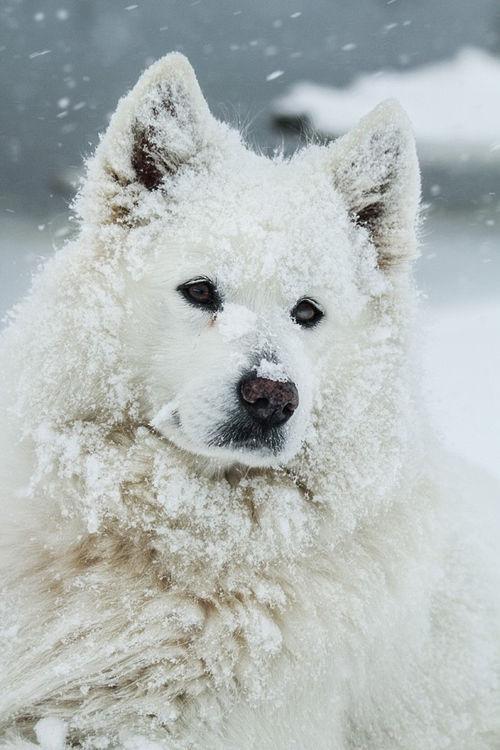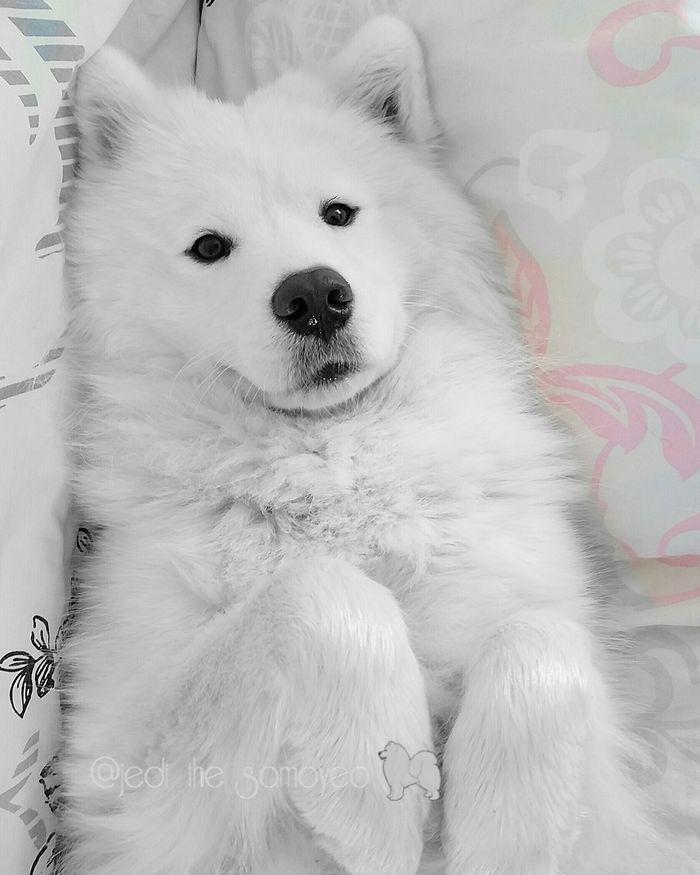The first image is the image on the left, the second image is the image on the right. For the images displayed, is the sentence "At least one image has an adult dog in it." factually correct? Answer yes or no. Yes. The first image is the image on the left, the second image is the image on the right. Considering the images on both sides, is "There is at least one white puppy sitting on the ground looking forward." valid? Answer yes or no. No. 